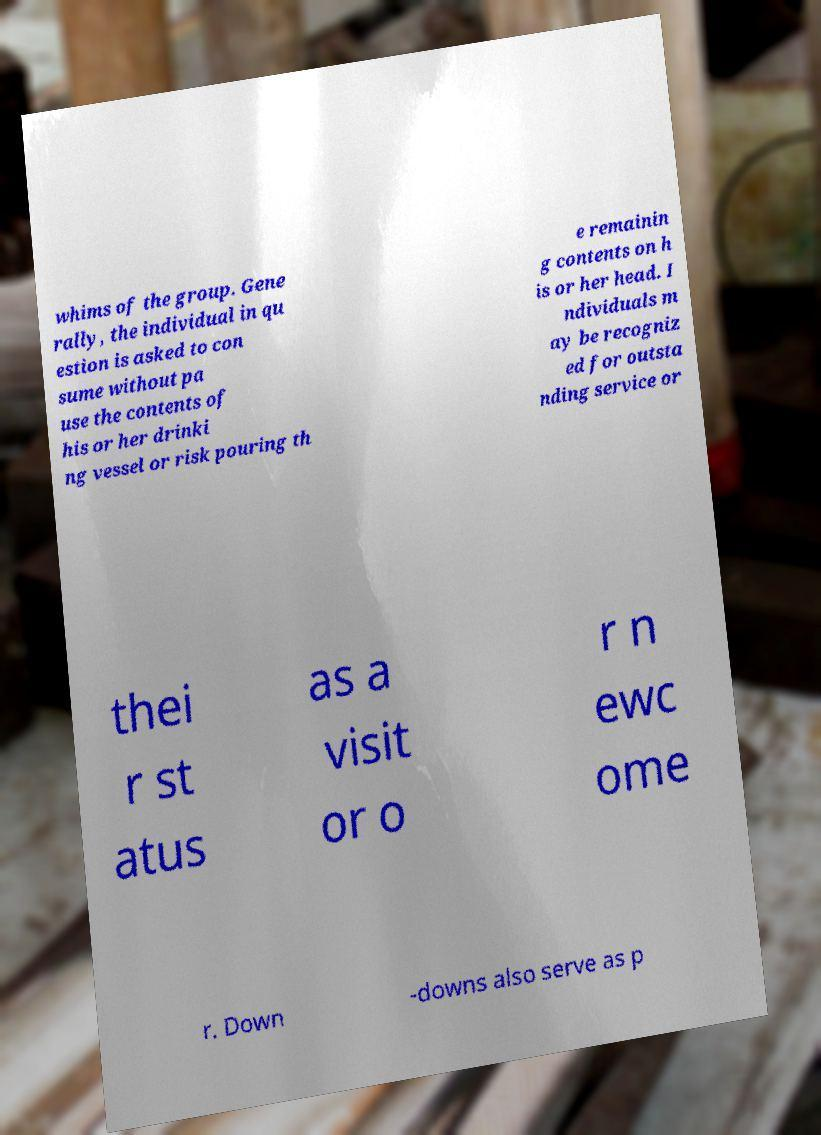Can you read and provide the text displayed in the image?This photo seems to have some interesting text. Can you extract and type it out for me? whims of the group. Gene rally, the individual in qu estion is asked to con sume without pa use the contents of his or her drinki ng vessel or risk pouring th e remainin g contents on h is or her head. I ndividuals m ay be recogniz ed for outsta nding service or thei r st atus as a visit or o r n ewc ome r. Down -downs also serve as p 